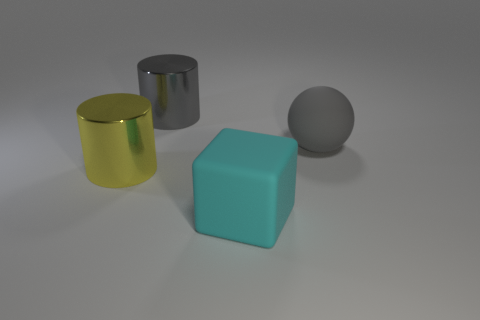Is there anything else that is the same shape as the large cyan matte object?
Offer a very short reply. No. What number of matte objects are green spheres or yellow cylinders?
Provide a short and direct response. 0. How many objects are gray cylinders or large gray metal objects behind the large cyan block?
Your answer should be compact. 1. There is a ball that is the same size as the cyan thing; what is it made of?
Your response must be concise. Rubber. There is a large object that is in front of the large gray metallic thing and to the left of the large cyan rubber cube; what material is it?
Make the answer very short. Metal. There is a big gray thing behind the large gray matte object; are there any gray metallic cylinders in front of it?
Offer a very short reply. No. There is a object that is on the left side of the matte block and in front of the big sphere; what size is it?
Offer a very short reply. Large. How many gray objects are either big cylinders or big spheres?
Provide a short and direct response. 2. The cyan object that is the same size as the gray rubber ball is what shape?
Provide a succinct answer. Cube. How many other objects are the same color as the large block?
Give a very brief answer. 0. 